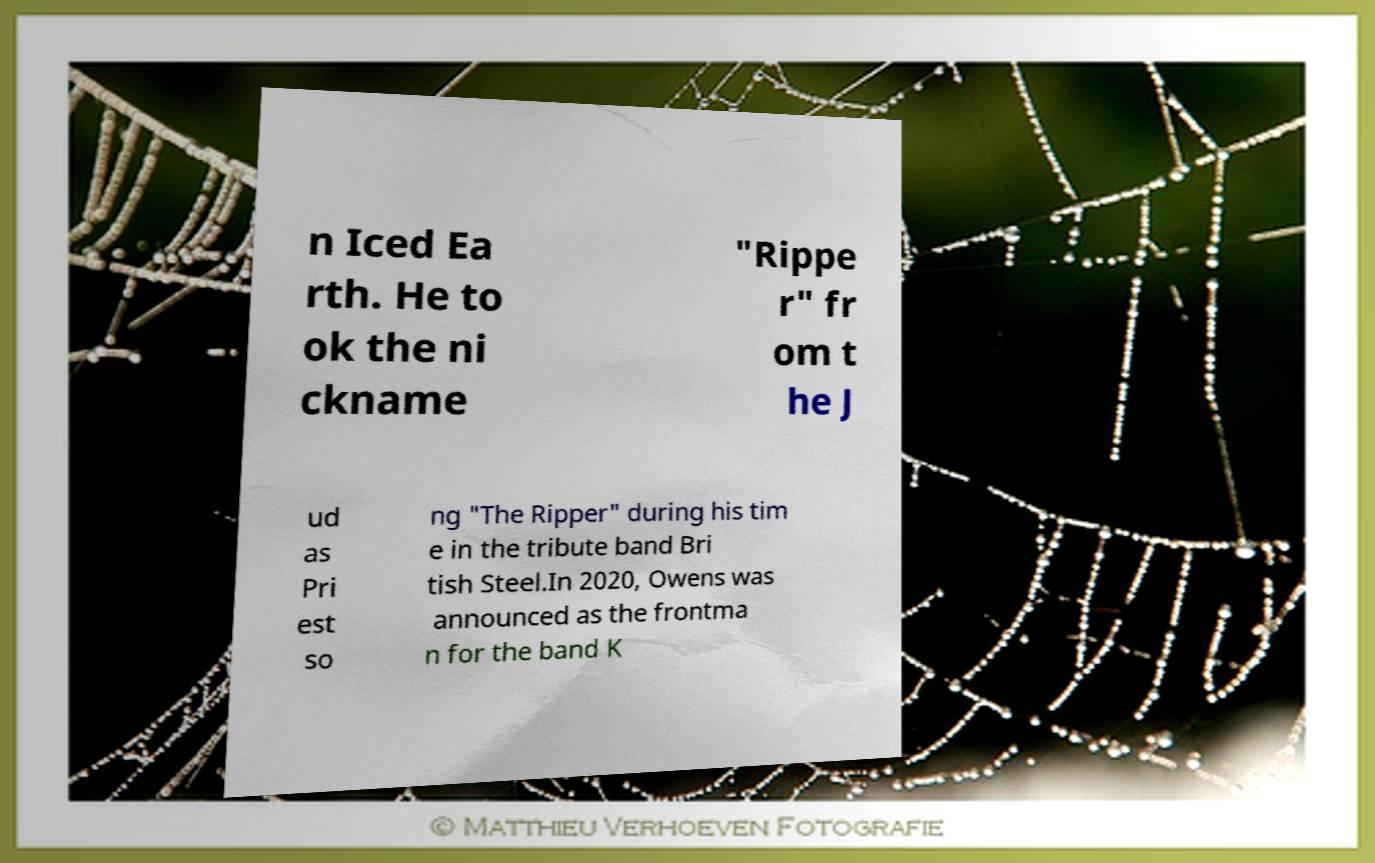What messages or text are displayed in this image? I need them in a readable, typed format. n Iced Ea rth. He to ok the ni ckname "Rippe r" fr om t he J ud as Pri est so ng "The Ripper" during his tim e in the tribute band Bri tish Steel.In 2020, Owens was announced as the frontma n for the band K 